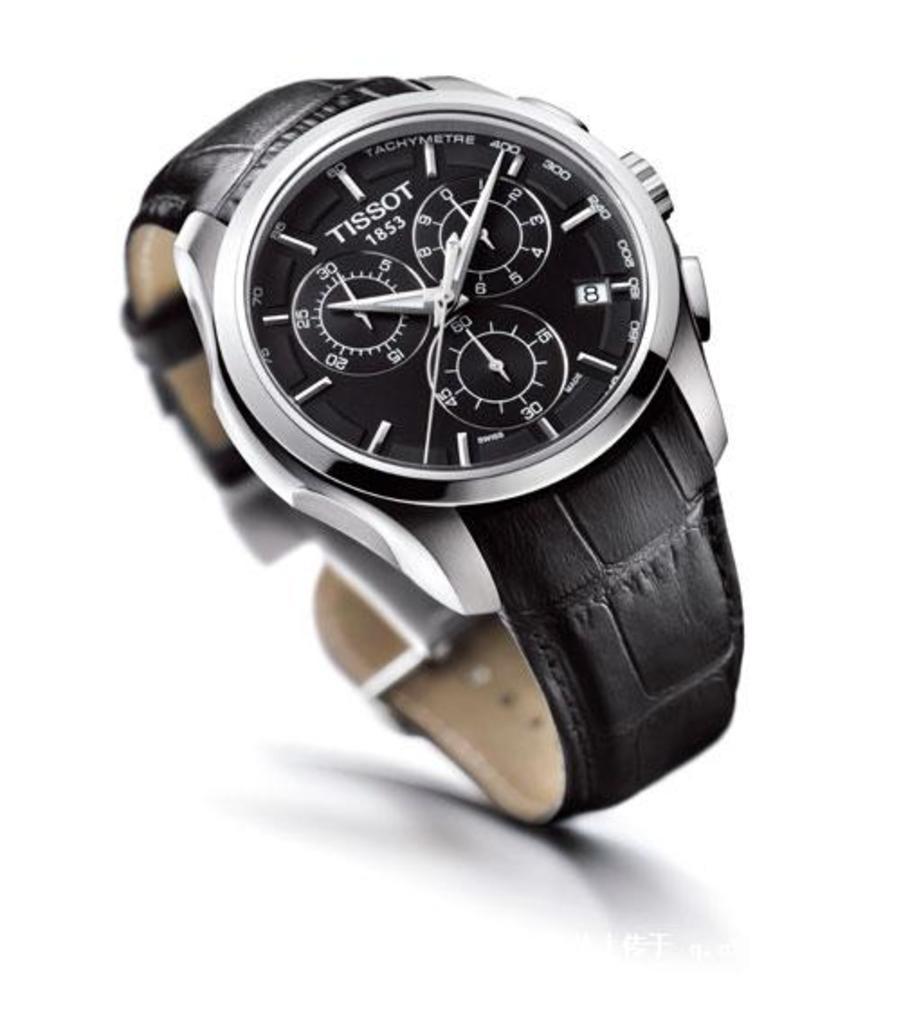What brand is the watch?
Make the answer very short. Tissot. What date is on the watch?
Your response must be concise. 1853. 